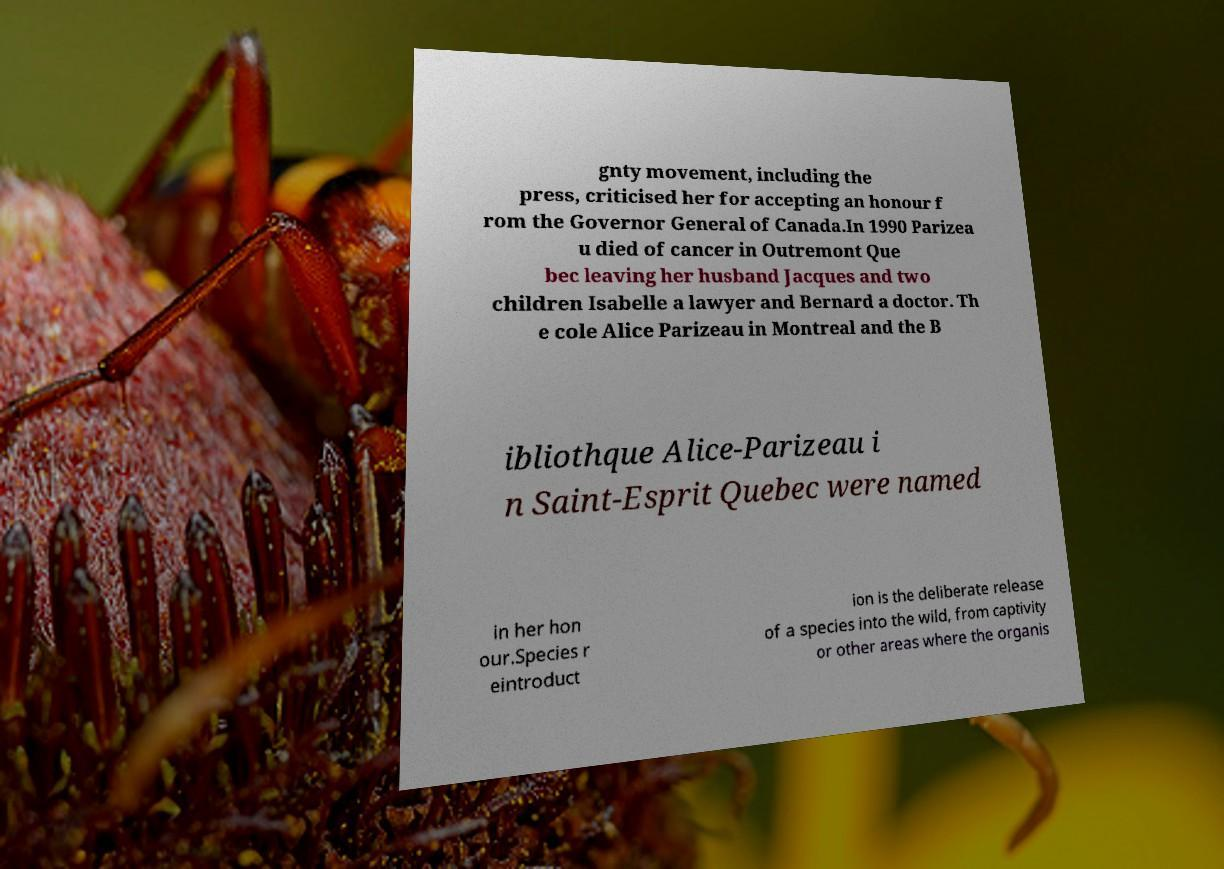For documentation purposes, I need the text within this image transcribed. Could you provide that? gnty movement, including the press, criticised her for accepting an honour f rom the Governor General of Canada.In 1990 Parizea u died of cancer in Outremont Que bec leaving her husband Jacques and two children Isabelle a lawyer and Bernard a doctor. Th e cole Alice Parizeau in Montreal and the B ibliothque Alice-Parizeau i n Saint-Esprit Quebec were named in her hon our.Species r eintroduct ion is the deliberate release of a species into the wild, from captivity or other areas where the organis 